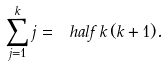<formula> <loc_0><loc_0><loc_500><loc_500>\sum _ { j = 1 } ^ { k } j = \ h a l f \, k \, ( k + 1 ) .</formula> 